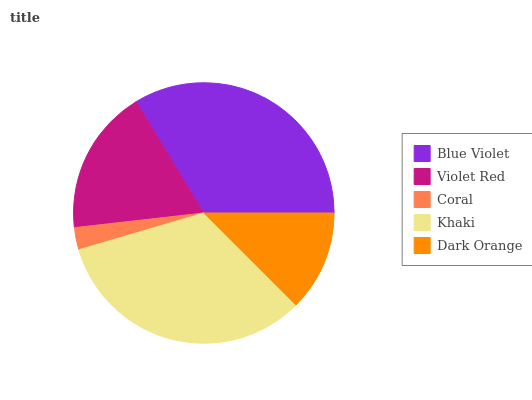Is Coral the minimum?
Answer yes or no. Yes. Is Blue Violet the maximum?
Answer yes or no. Yes. Is Violet Red the minimum?
Answer yes or no. No. Is Violet Red the maximum?
Answer yes or no. No. Is Blue Violet greater than Violet Red?
Answer yes or no. Yes. Is Violet Red less than Blue Violet?
Answer yes or no. Yes. Is Violet Red greater than Blue Violet?
Answer yes or no. No. Is Blue Violet less than Violet Red?
Answer yes or no. No. Is Violet Red the high median?
Answer yes or no. Yes. Is Violet Red the low median?
Answer yes or no. Yes. Is Khaki the high median?
Answer yes or no. No. Is Blue Violet the low median?
Answer yes or no. No. 